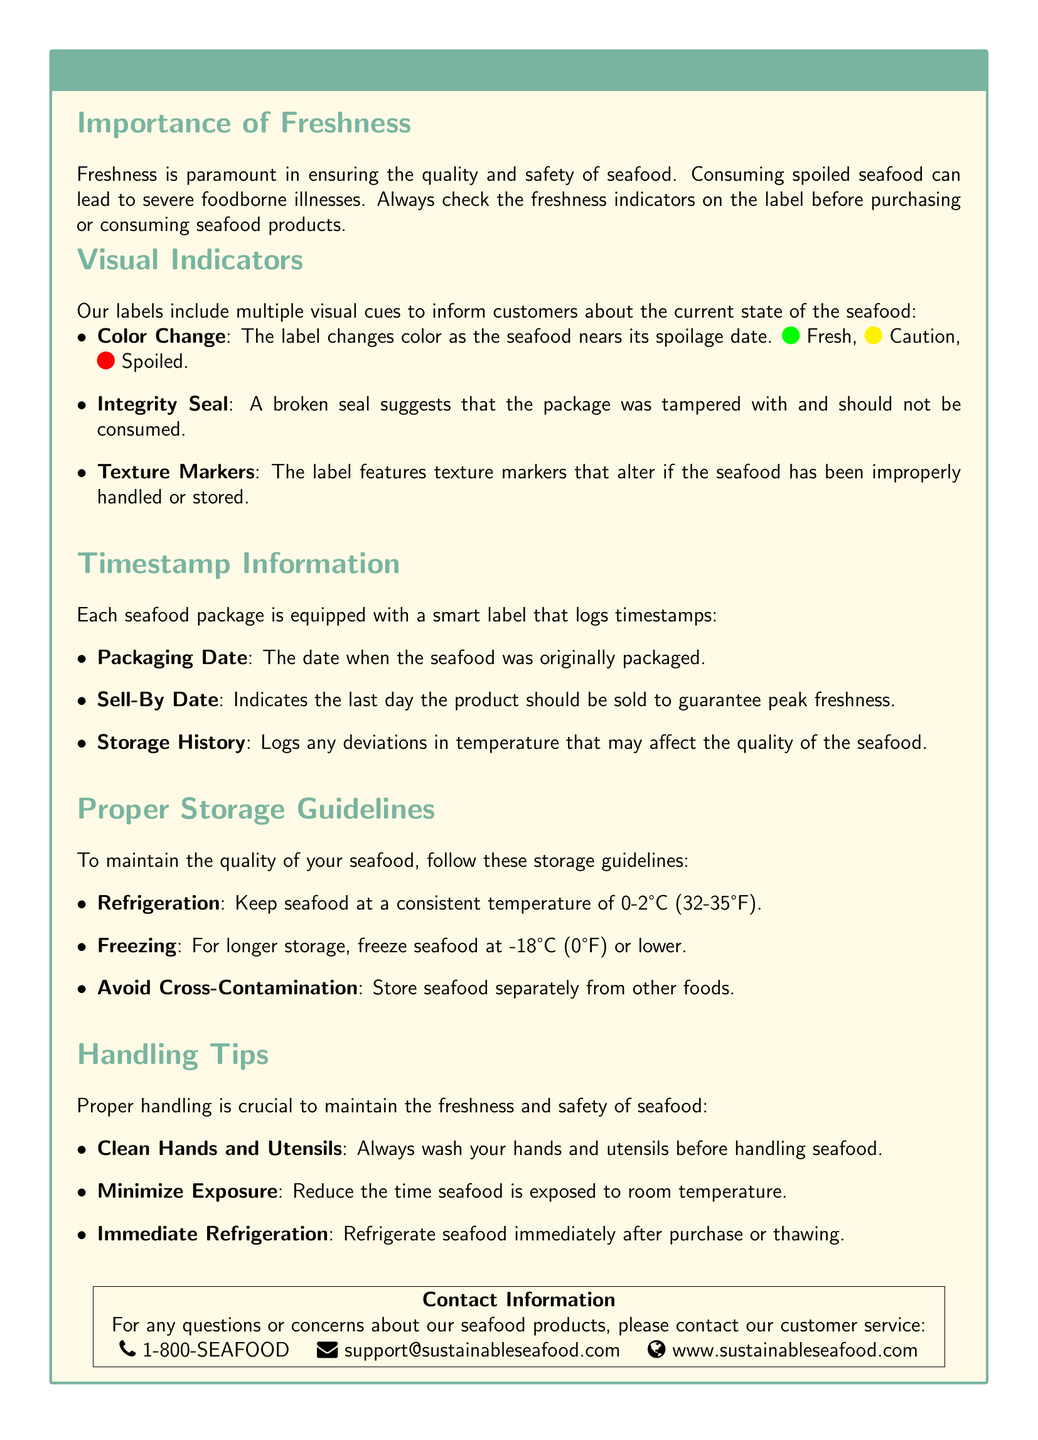What is the color indicating freshness? The document specifies that the color indicating freshness is green.
Answer: Green What should be the refrigeration temperature for seafood? According to the document, seafood should be kept at a consistent temperature of 0-2 degrees Celsius.
Answer: 0-2°C What date is logged to guarantee peak freshness? The document mentions the sell-by date as the date that guarantees peak freshness.
Answer: Sell-By Date What happens to the label if the seafood has been improperly handled? The document states that texture markers on the label alter if the seafood has been improperly handled or stored.
Answer: Texture markers alter What does a broken integrity seal suggest? The document indicates that a broken seal suggests that the package was tampered with and should not be consumed.
Answer: Tampered with Which method is recommended for longer storage of seafood? The document recommends freezing seafood for longer storage.
Answer: Freezing What color change indicates caution? The document specifies that the color indicating caution is yellow.
Answer: Yellow How can customers contact support for questions about seafood products? The document provides the contact number 1-800-SEAFOOD for customer service inquiries.
Answer: 1-800-SEAFOOD What is the packaging date used for? The packaging date logs when the seafood was originally packaged, as per the document.
Answer: Original packaging date 